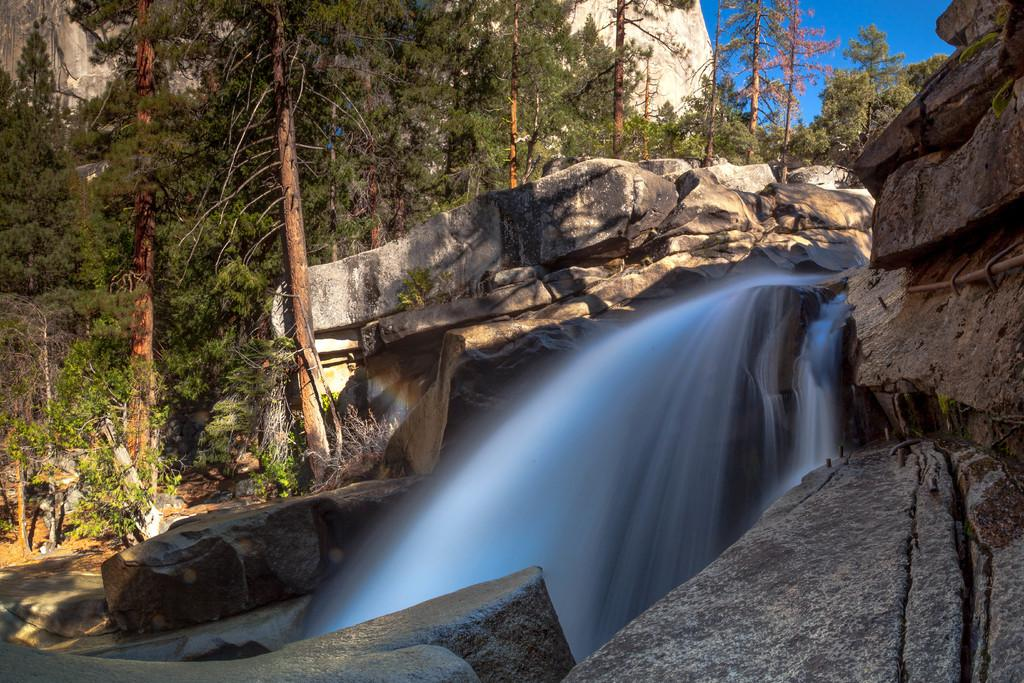What is the main feature in the center of the image? There is a waterfall in the center of the image. What can be seen in the background of the image? There are trees and rocks in the background of the image. What is visible above the trees and rocks in the image? The sky is visible in the background of the image. How many pieces of pie are on the rocks in the image? There is no pie present in the image; it features a waterfall, trees, rocks, and the sky. Can you see any lizards near the waterfall in the image? There are no lizards visible in the image; it only features a waterfall, trees, rocks, and the sky. 